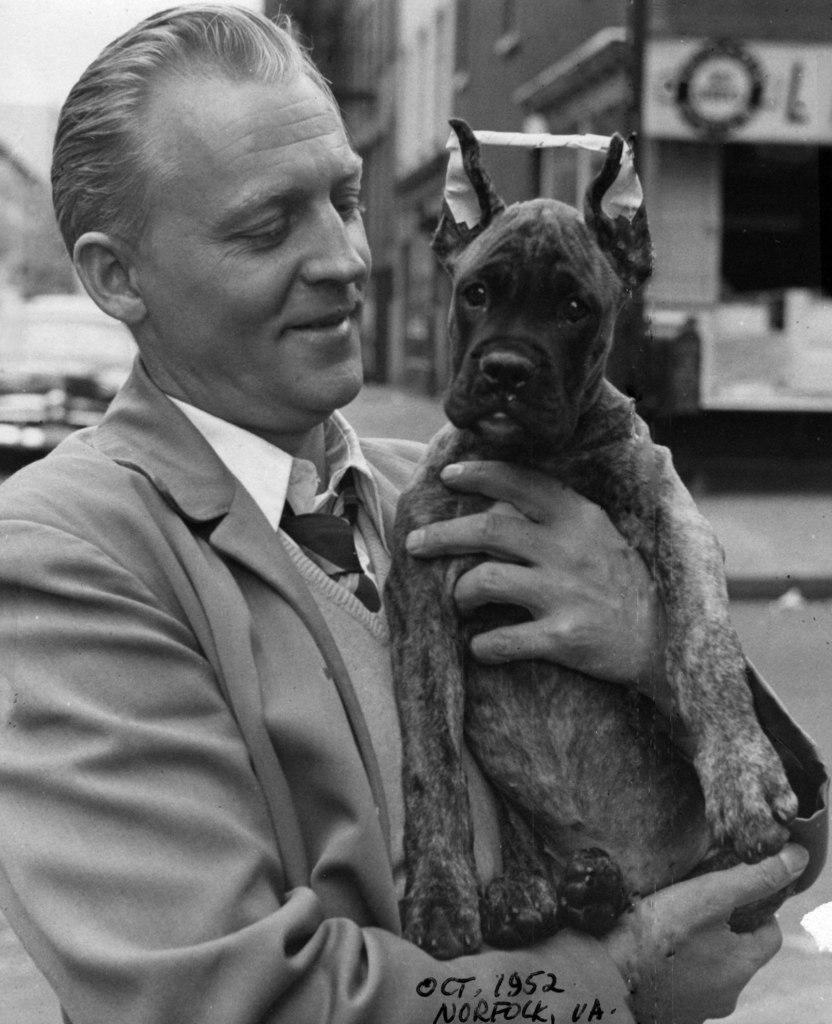Who is the main subject in the image? There is a man in the image. What is the man wearing? The man is wearing a suit. What is the man doing with the dog? The man is holding a dog. What is the man's facial expression? The man is smiling. What can be seen in the background of the image? There is a car and buildings in the background of the image. What type of writer is the man in the image? There is no indication in the image that the man is a writer, as the facts provided do not mention anything related to writing. 